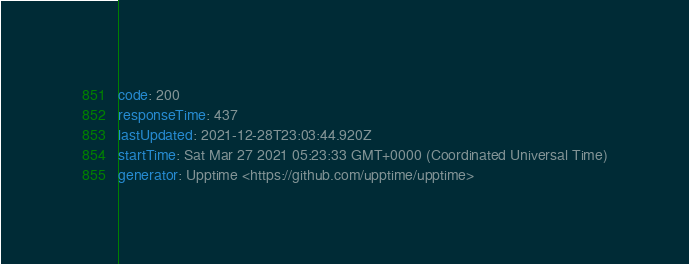<code> <loc_0><loc_0><loc_500><loc_500><_YAML_>code: 200
responseTime: 437
lastUpdated: 2021-12-28T23:03:44.920Z
startTime: Sat Mar 27 2021 05:23:33 GMT+0000 (Coordinated Universal Time)
generator: Upptime <https://github.com/upptime/upptime>
</code> 